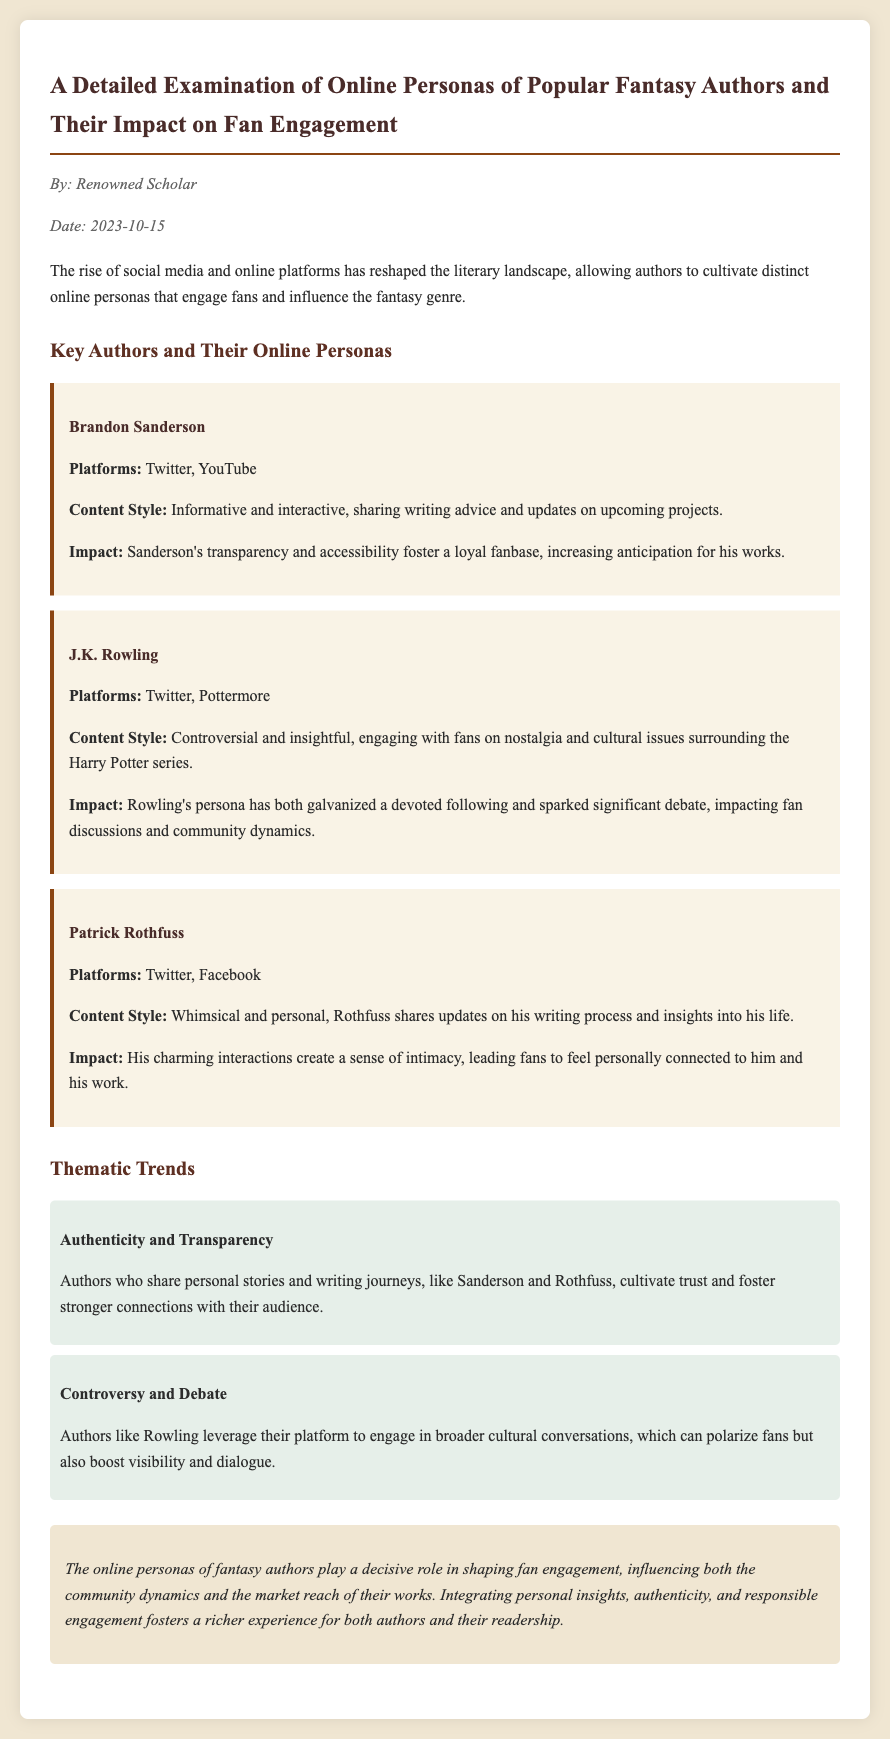what is the title of the memo? The title of the memo is explicitly stated at the beginning of the document.
Answer: A Detailed Examination of Online Personas of Popular Fantasy Authors and Their Impact on Fan Engagement who is the author of the memo? The author of the memo is mentioned in the author info section.
Answer: Renowned Scholar what platforms does Brandon Sanderson use? The platforms used by Brandon Sanderson are listed under his author card in the document.
Answer: Twitter, YouTube what impact does J.K. Rowling's persona have? The impact of J.K. Rowling's persona is detailed in her author card.
Answer: Galvanized a devoted following and sparked significant debate what thematic trend involves personal stories? The thematic trend that involves personal stories and writing journeys is discussed in the thematic trends section.
Answer: Authenticity and Transparency how does Patrick Rothfuss's content style affect fan engagement? The content style of Patrick Rothfuss is linked to a sense of intimacy with fans in the document.
Answer: Creates a sense of intimacy what is the date of the memo? The date of the memo is noted in the author info section.
Answer: 2023-10-15 which author is noted for engaging in cultural conversations? The document specifies which author engages in broader cultural conversations.
Answer: J.K. Rowling 